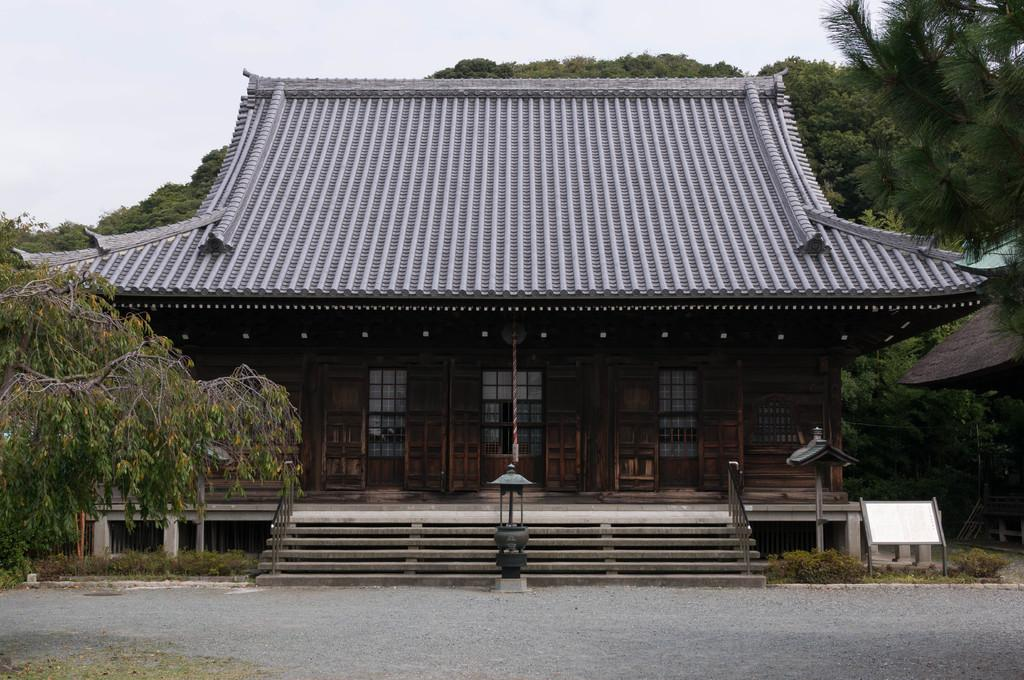What type of structures can be seen in the image? There are buildings in the image. What can be seen in the background of the image? There are trees in the background of the image. What object is present in the image that might be used for displaying information or messages? There is a board in the image. What is visible in the image that represents the atmosphere? The sky is visible in the image. How would you describe the weather based on the appearance of the sky in the image? The sky appears to be cloudy in the image. What type of quiet substance can be found in the pocket of the person in the image? There is no person in the image, and therefore no pocket or substance to be found. 